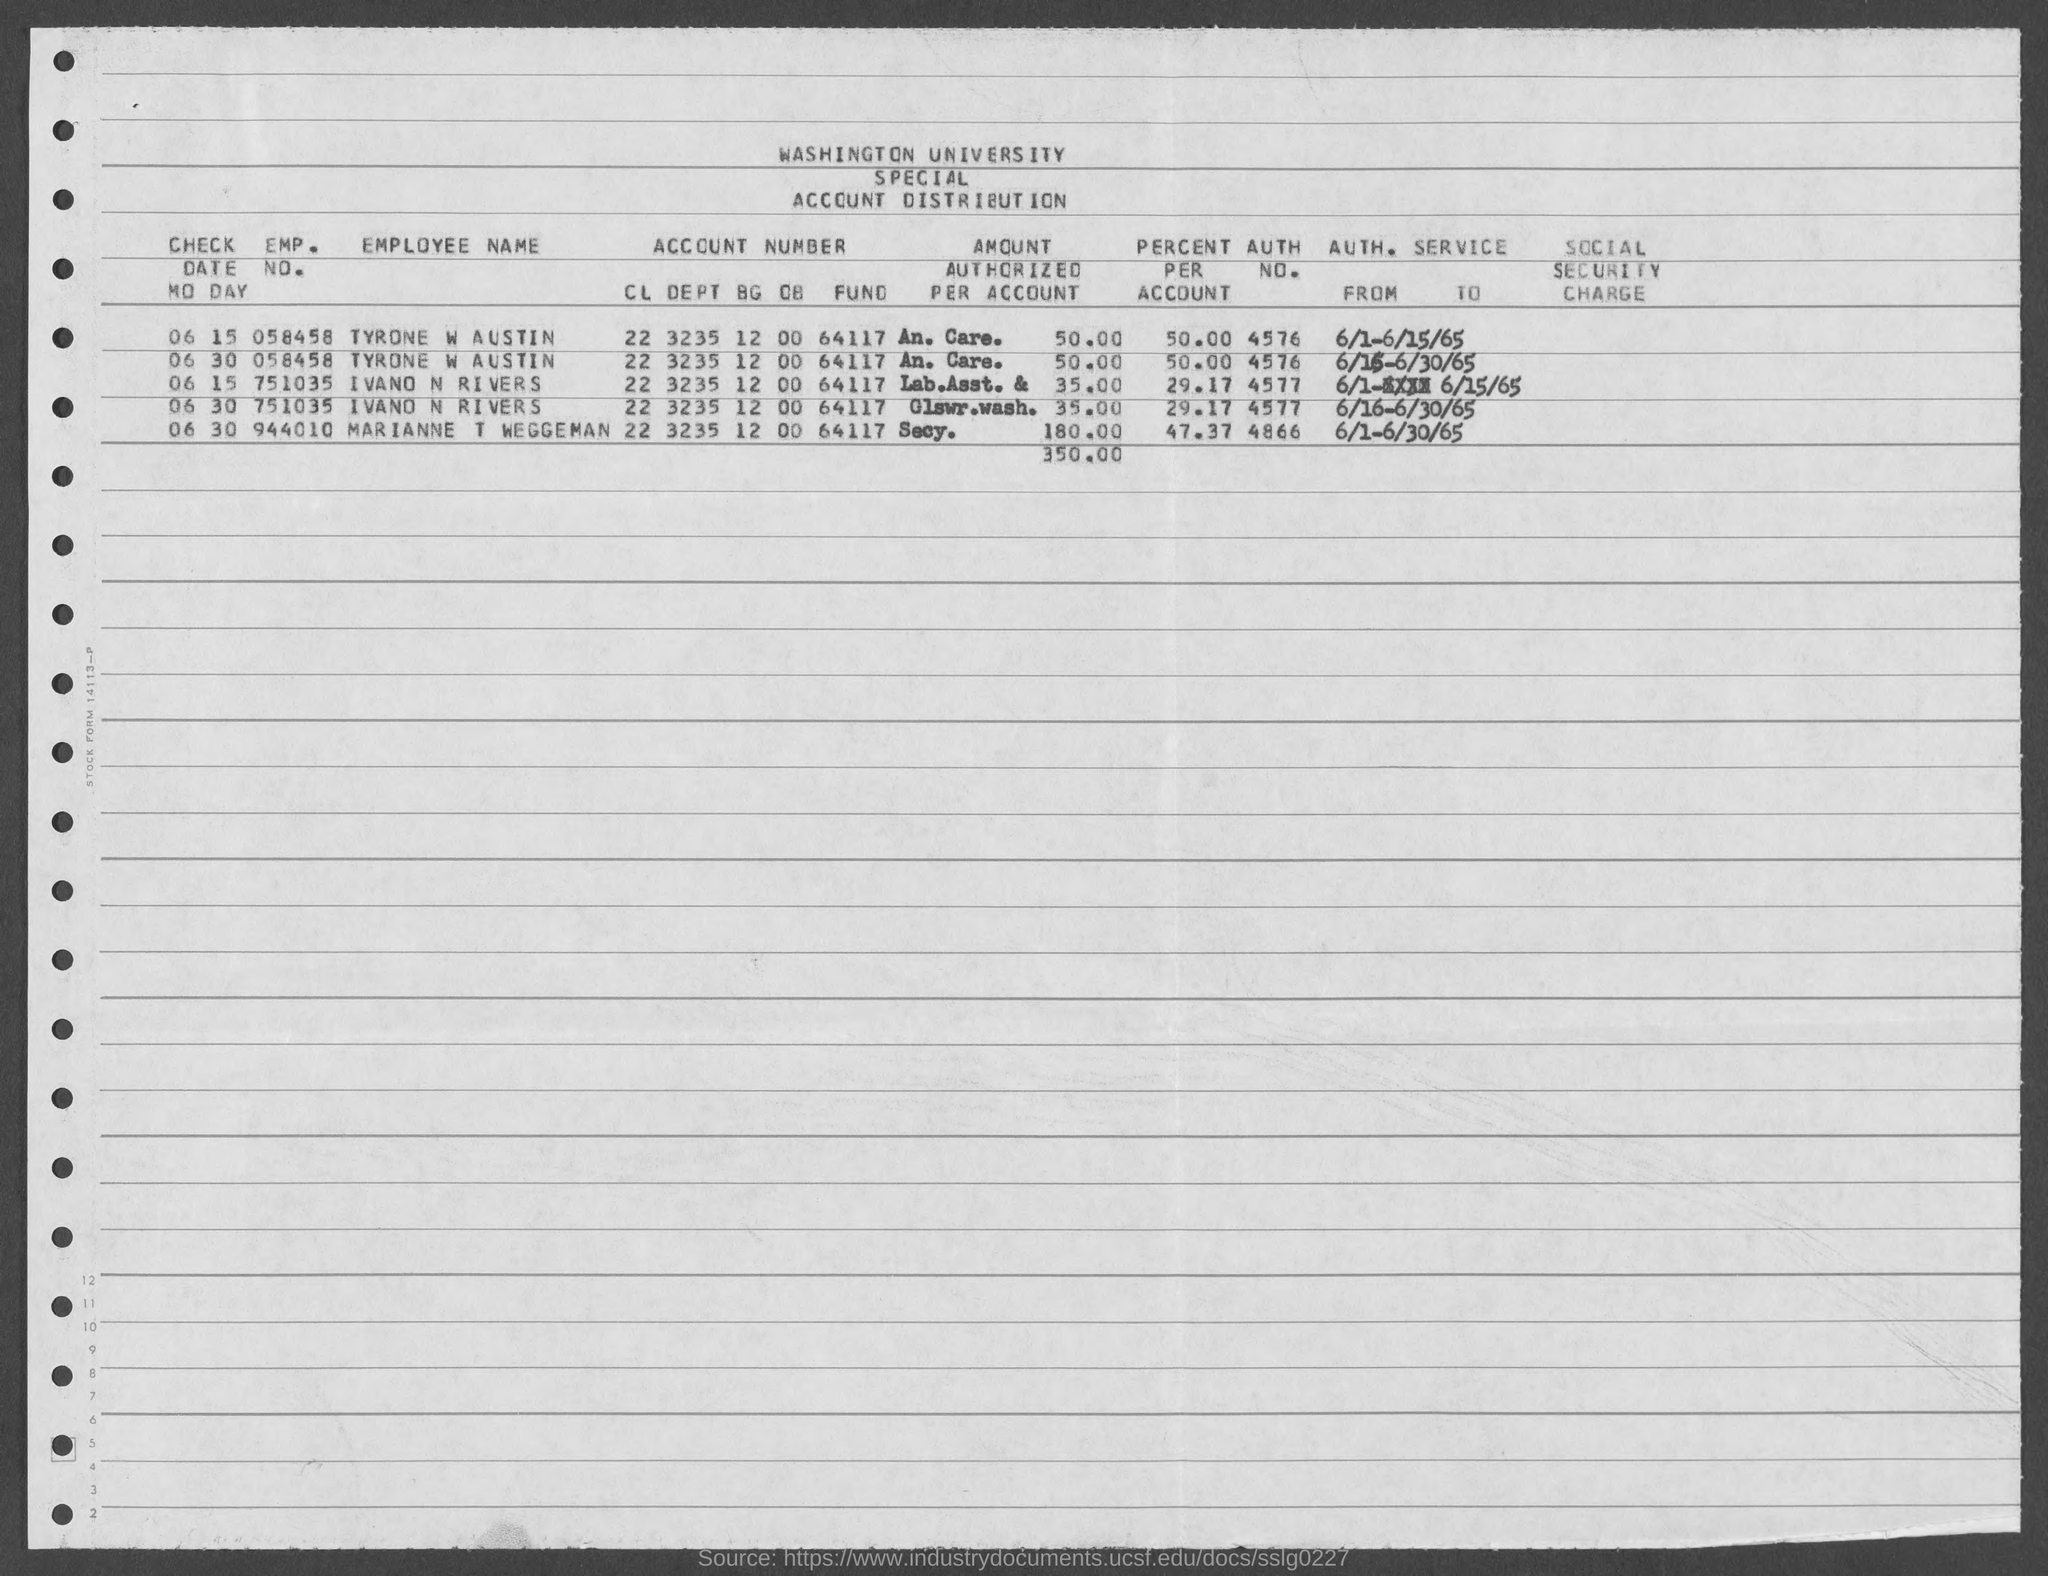What is the AUTH. NO. of IVANO N RIVERS given in the document?
Ensure brevity in your answer.  4577. What is the AUTH. NO. of TYRONE W AUSTIN given in the document?
Ensure brevity in your answer.  4576. What is the percent per account of TYRONE W AUSTIN?
Keep it short and to the point. 50.00. 